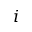Convert formula to latex. <formula><loc_0><loc_0><loc_500><loc_500>i</formula> 